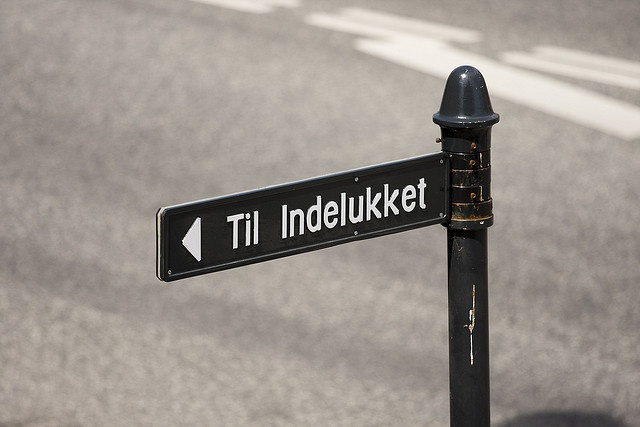Describe the objects in this image and their specific colors. I can see various objects in this image with different colors. 